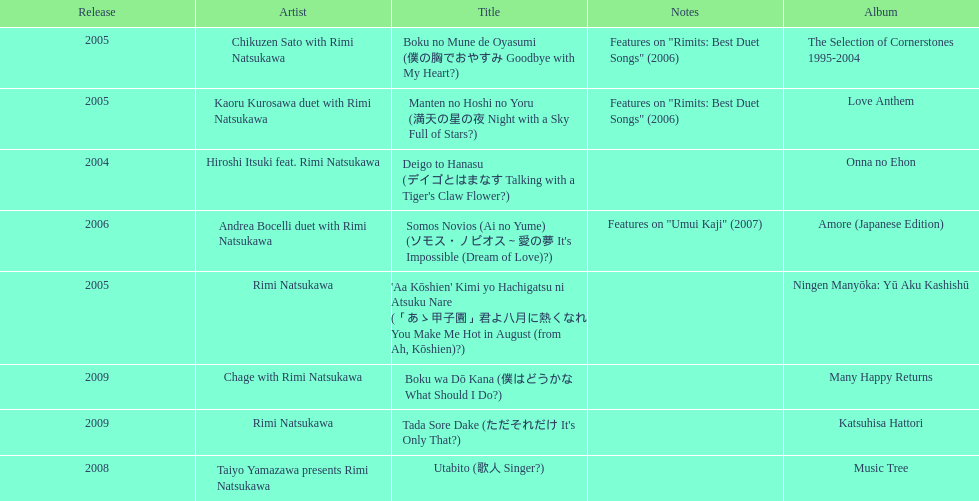Which was not released in 2004, onna no ehon or music tree? Music Tree. 